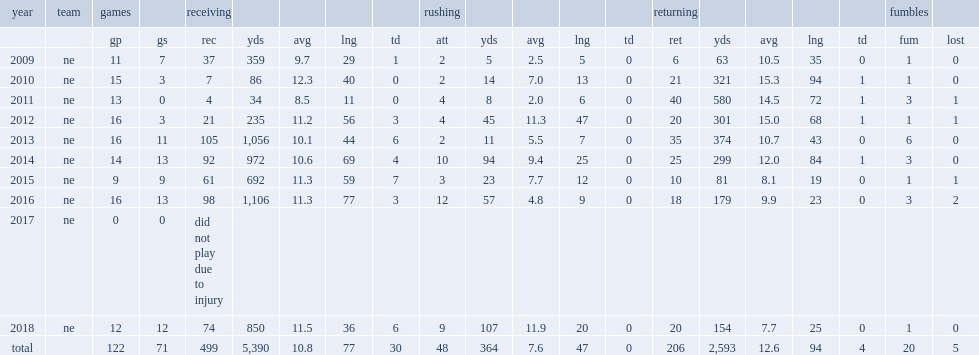How many yards did edelman set a record by averaging per return? 15.3. 